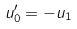<formula> <loc_0><loc_0><loc_500><loc_500>u _ { 0 } ^ { \prime } = - u _ { 1 }</formula> 